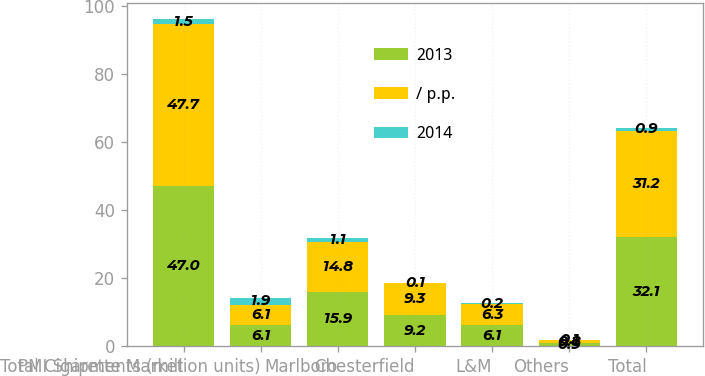Convert chart to OTSL. <chart><loc_0><loc_0><loc_500><loc_500><stacked_bar_chart><ecel><fcel>Total Cigarette Market<fcel>PMI Shipments (million units)<fcel>Marlboro<fcel>Chesterfield<fcel>L&M<fcel>Others<fcel>Total<nl><fcel>2013<fcel>47<fcel>6.1<fcel>15.9<fcel>9.2<fcel>6.1<fcel>0.9<fcel>32.1<nl><fcel>/ p.p.<fcel>47.7<fcel>6.1<fcel>14.8<fcel>9.3<fcel>6.3<fcel>0.8<fcel>31.2<nl><fcel>2014<fcel>1.5<fcel>1.9<fcel>1.1<fcel>0.1<fcel>0.2<fcel>0.1<fcel>0.9<nl></chart> 